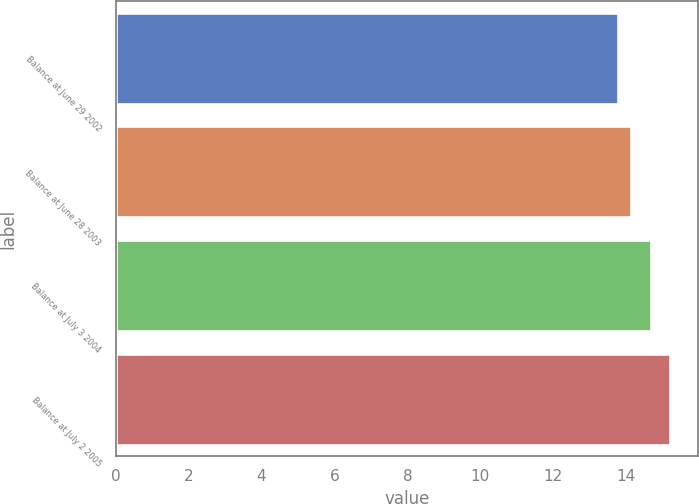Convert chart to OTSL. <chart><loc_0><loc_0><loc_500><loc_500><bar_chart><fcel>Balance at June 29 2002<fcel>Balance at June 28 2003<fcel>Balance at July 3 2004<fcel>Balance at July 2 2005<nl><fcel>13.78<fcel>14.12<fcel>14.68<fcel>15.2<nl></chart> 